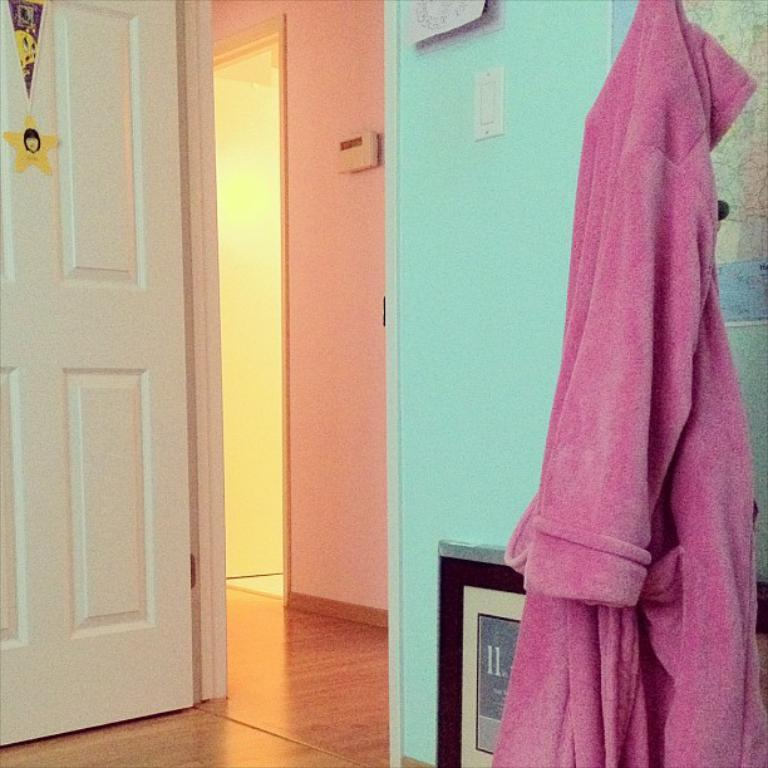What type of space is depicted in the image? The image shows an inner view of a room. Are there any specific features in the room? Yes, there is a door and a frame in the room. What can be seen hanging in the room? There is a cloth hanging in the room. What color is the cloth? The cloth is pink in color. How does the parcel get signed in the image? There is no parcel present in the image, so it cannot be signed. What type of agreement is being made in the image? There is no agreement being made in the image; it simply shows an inner view of a room with a door, frame, and pink cloth. 